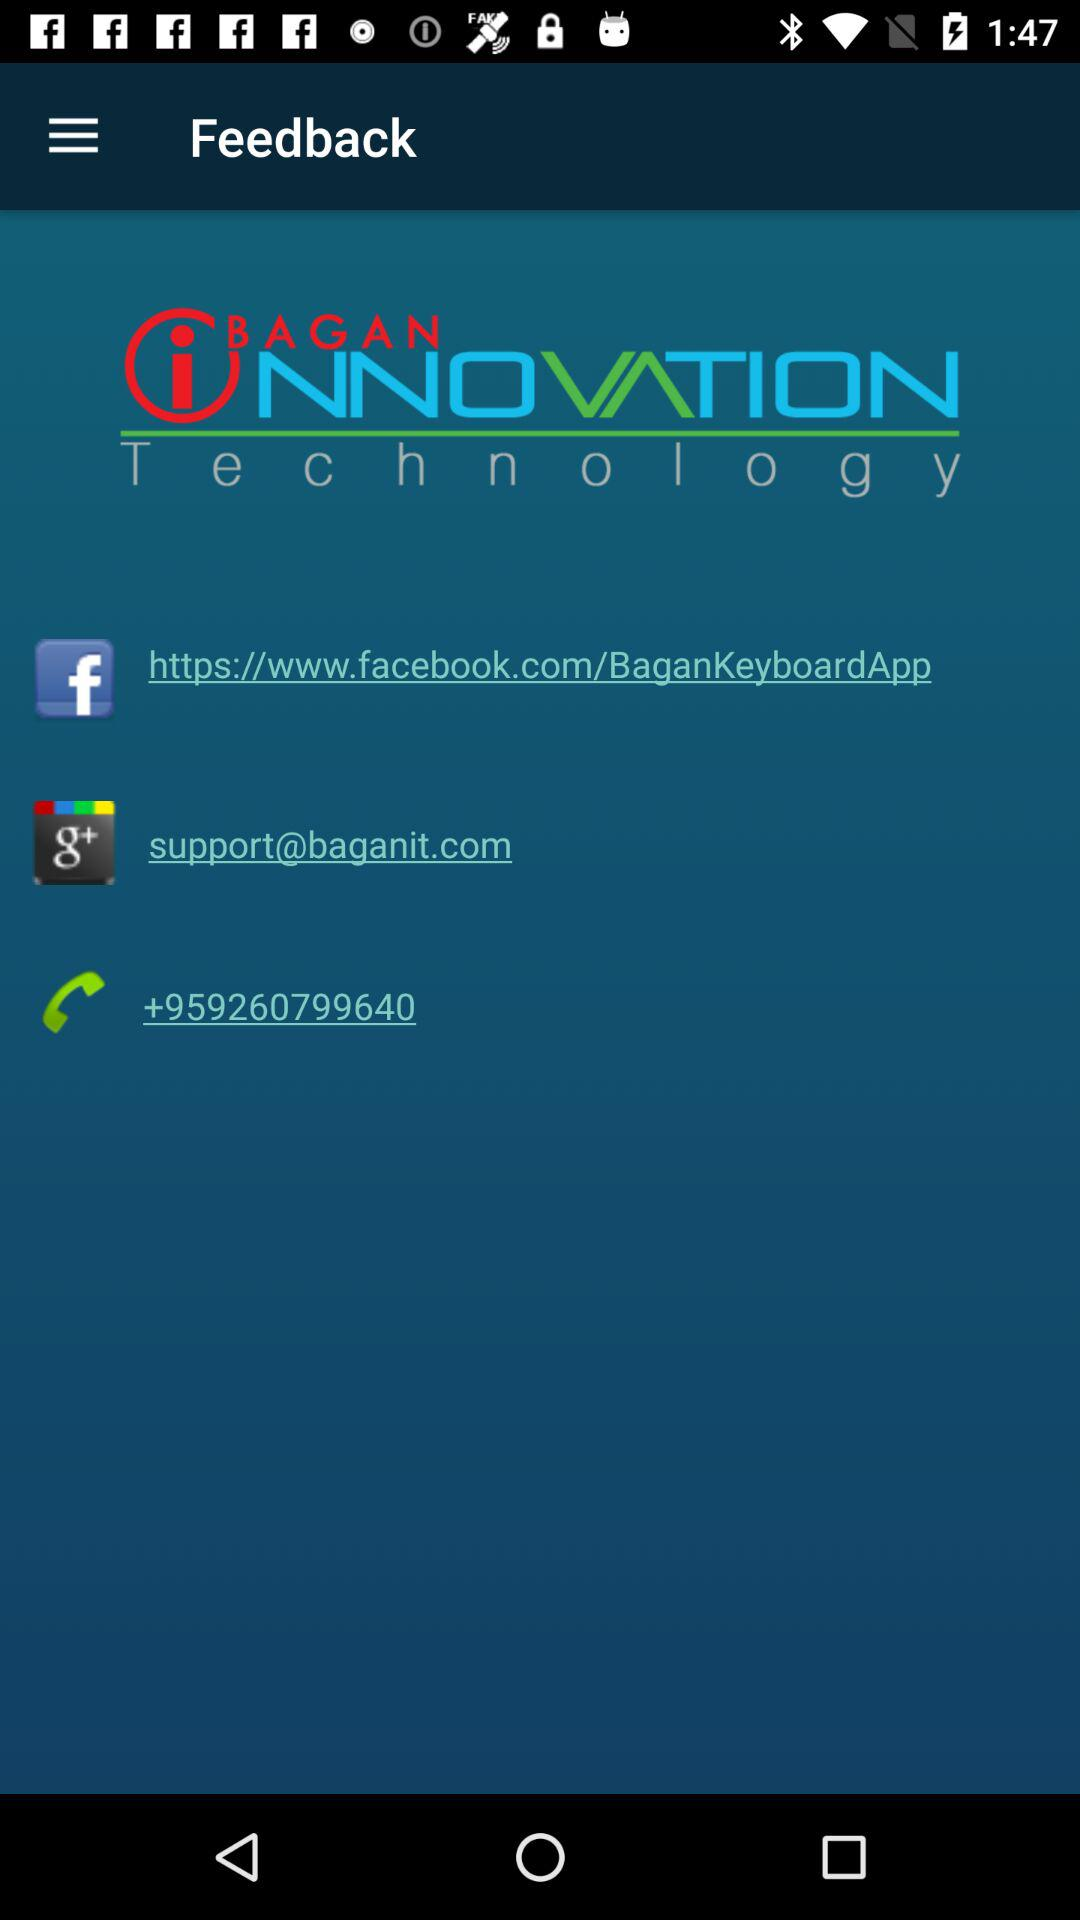What is the email address? The email address is support@baganit.com. 